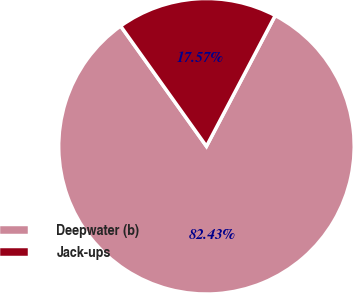Convert chart to OTSL. <chart><loc_0><loc_0><loc_500><loc_500><pie_chart><fcel>Deepwater (b)<fcel>Jack-ups<nl><fcel>82.43%<fcel>17.57%<nl></chart> 